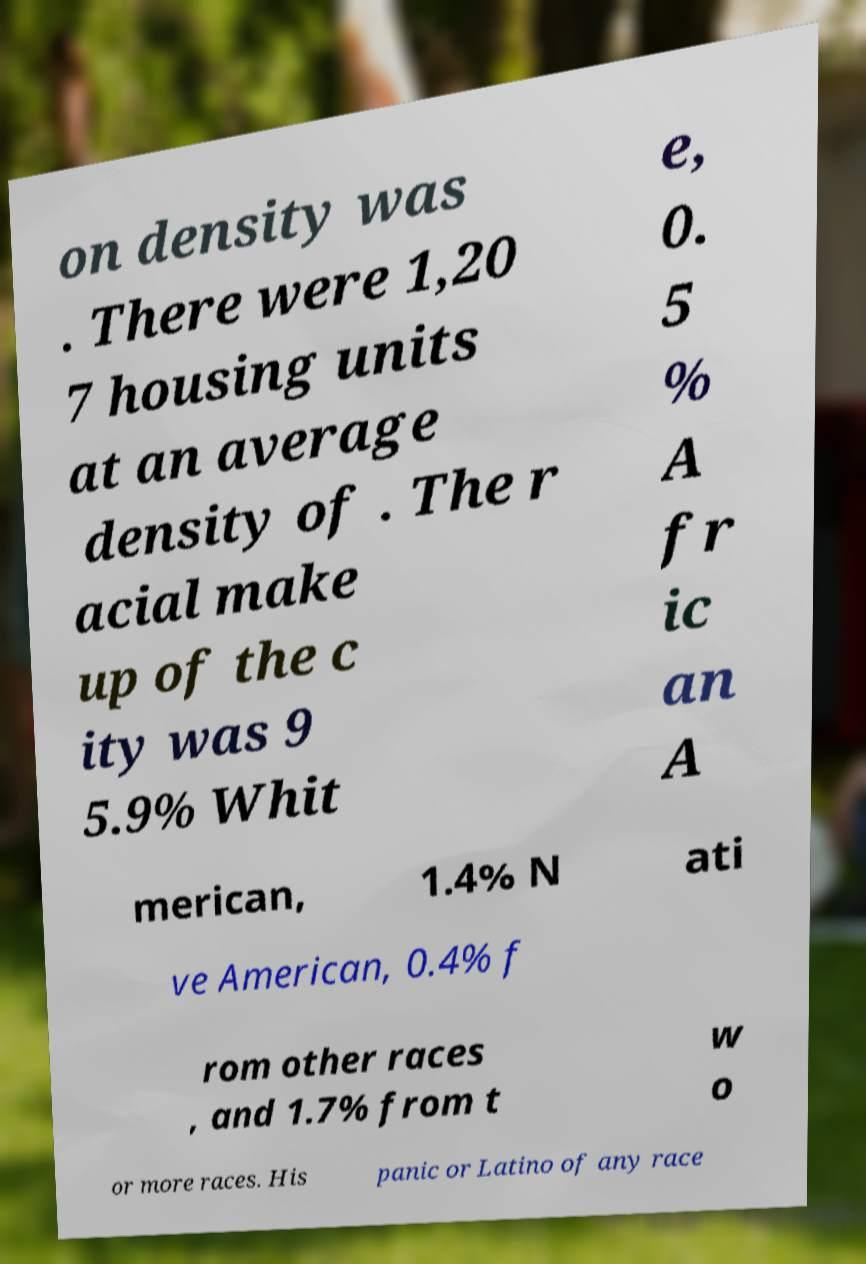What messages or text are displayed in this image? I need them in a readable, typed format. on density was . There were 1,20 7 housing units at an average density of . The r acial make up of the c ity was 9 5.9% Whit e, 0. 5 % A fr ic an A merican, 1.4% N ati ve American, 0.4% f rom other races , and 1.7% from t w o or more races. His panic or Latino of any race 